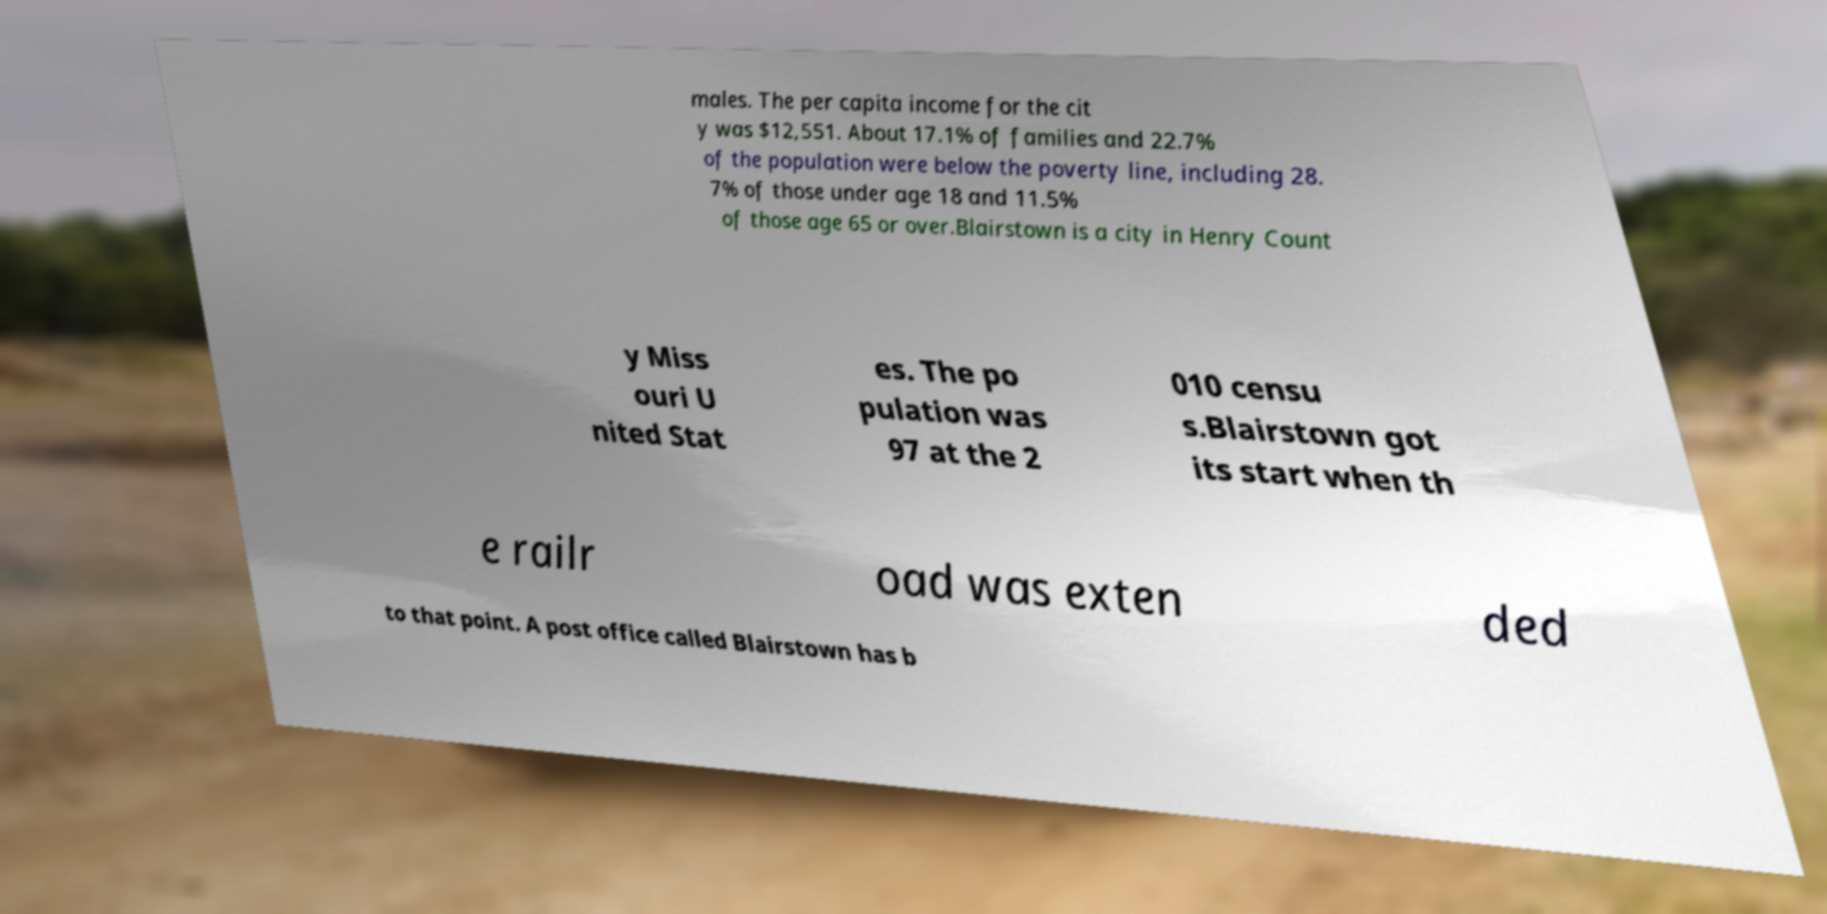Please identify and transcribe the text found in this image. males. The per capita income for the cit y was $12,551. About 17.1% of families and 22.7% of the population were below the poverty line, including 28. 7% of those under age 18 and 11.5% of those age 65 or over.Blairstown is a city in Henry Count y Miss ouri U nited Stat es. The po pulation was 97 at the 2 010 censu s.Blairstown got its start when th e railr oad was exten ded to that point. A post office called Blairstown has b 